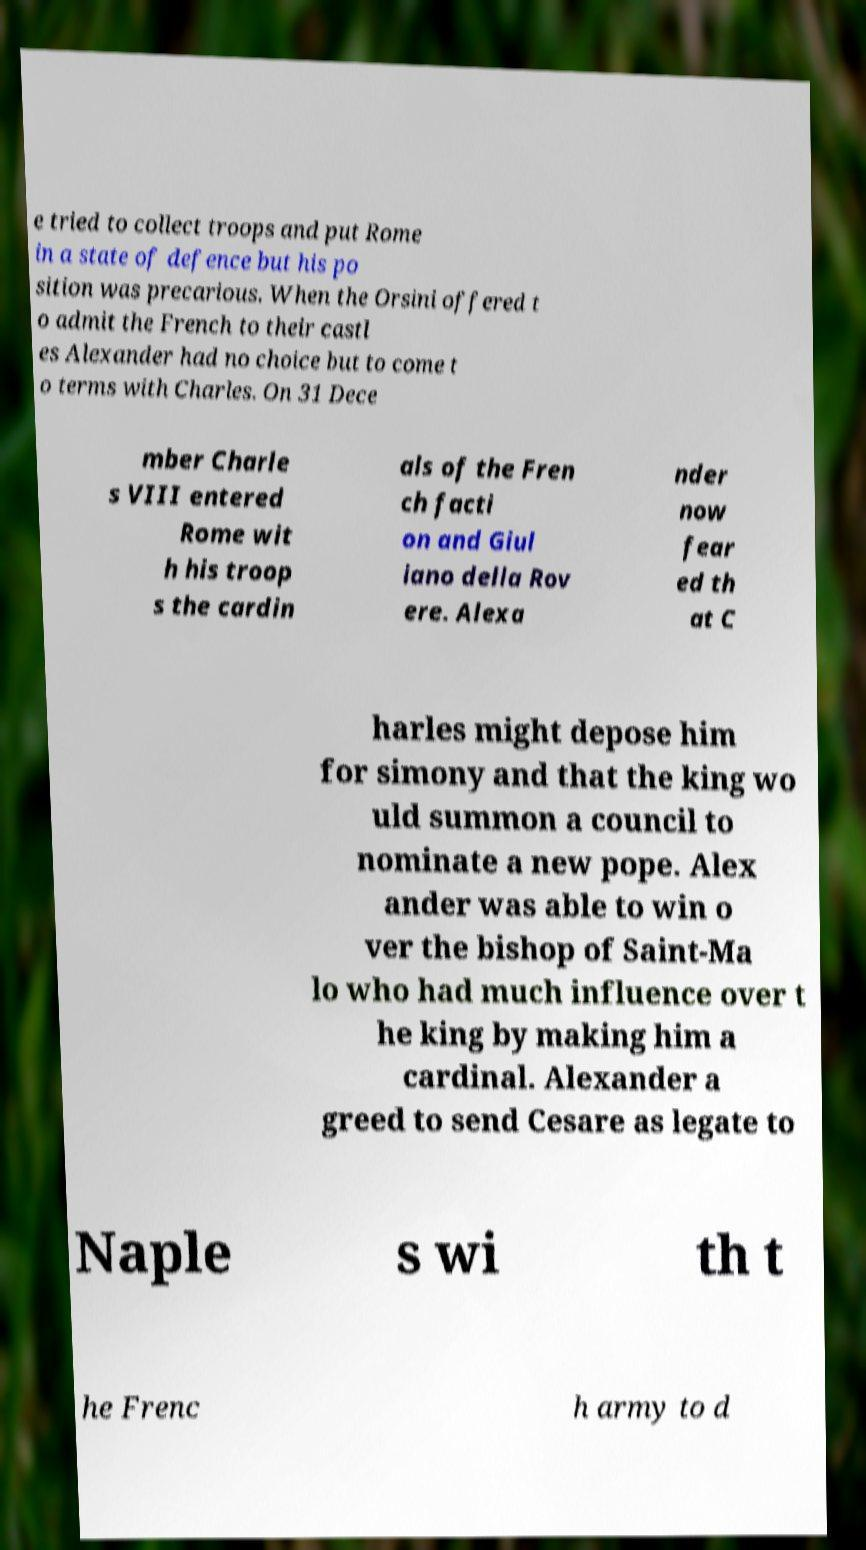Can you read and provide the text displayed in the image?This photo seems to have some interesting text. Can you extract and type it out for me? e tried to collect troops and put Rome in a state of defence but his po sition was precarious. When the Orsini offered t o admit the French to their castl es Alexander had no choice but to come t o terms with Charles. On 31 Dece mber Charle s VIII entered Rome wit h his troop s the cardin als of the Fren ch facti on and Giul iano della Rov ere. Alexa nder now fear ed th at C harles might depose him for simony and that the king wo uld summon a council to nominate a new pope. Alex ander was able to win o ver the bishop of Saint-Ma lo who had much influence over t he king by making him a cardinal. Alexander a greed to send Cesare as legate to Naple s wi th t he Frenc h army to d 